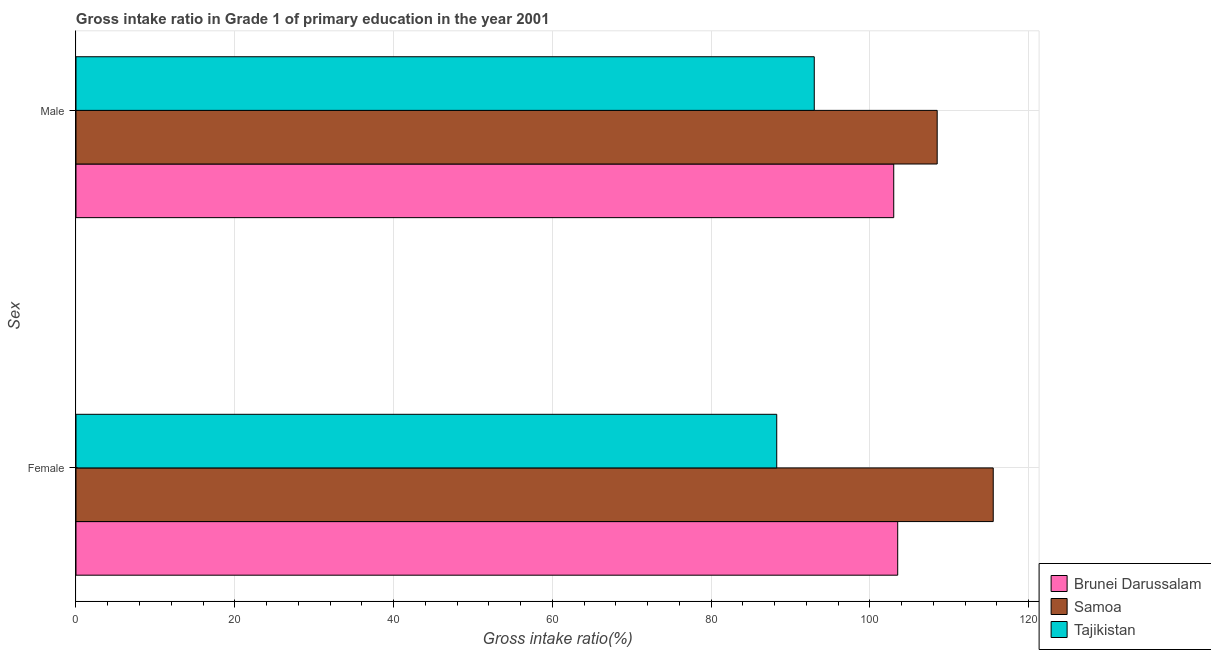How many different coloured bars are there?
Provide a succinct answer. 3. How many bars are there on the 1st tick from the bottom?
Your answer should be compact. 3. What is the label of the 2nd group of bars from the top?
Your response must be concise. Female. What is the gross intake ratio(female) in Tajikistan?
Keep it short and to the point. 88.27. Across all countries, what is the maximum gross intake ratio(female)?
Your response must be concise. 115.54. Across all countries, what is the minimum gross intake ratio(female)?
Ensure brevity in your answer.  88.27. In which country was the gross intake ratio(male) maximum?
Ensure brevity in your answer.  Samoa. In which country was the gross intake ratio(male) minimum?
Give a very brief answer. Tajikistan. What is the total gross intake ratio(male) in the graph?
Keep it short and to the point. 304.48. What is the difference between the gross intake ratio(female) in Samoa and that in Brunei Darussalam?
Give a very brief answer. 12.03. What is the difference between the gross intake ratio(female) in Samoa and the gross intake ratio(male) in Brunei Darussalam?
Your response must be concise. 12.53. What is the average gross intake ratio(male) per country?
Your answer should be very brief. 101.49. What is the difference between the gross intake ratio(male) and gross intake ratio(female) in Brunei Darussalam?
Keep it short and to the point. -0.5. What is the ratio of the gross intake ratio(female) in Tajikistan to that in Samoa?
Provide a short and direct response. 0.76. In how many countries, is the gross intake ratio(male) greater than the average gross intake ratio(male) taken over all countries?
Provide a short and direct response. 2. What does the 2nd bar from the top in Male represents?
Make the answer very short. Samoa. What does the 1st bar from the bottom in Male represents?
Give a very brief answer. Brunei Darussalam. How many countries are there in the graph?
Make the answer very short. 3. Are the values on the major ticks of X-axis written in scientific E-notation?
Make the answer very short. No. Does the graph contain any zero values?
Offer a terse response. No. Does the graph contain grids?
Give a very brief answer. Yes. How many legend labels are there?
Offer a terse response. 3. How are the legend labels stacked?
Give a very brief answer. Vertical. What is the title of the graph?
Offer a very short reply. Gross intake ratio in Grade 1 of primary education in the year 2001. What is the label or title of the X-axis?
Make the answer very short. Gross intake ratio(%). What is the label or title of the Y-axis?
Give a very brief answer. Sex. What is the Gross intake ratio(%) of Brunei Darussalam in Female?
Make the answer very short. 103.5. What is the Gross intake ratio(%) in Samoa in Female?
Ensure brevity in your answer.  115.54. What is the Gross intake ratio(%) in Tajikistan in Female?
Provide a short and direct response. 88.27. What is the Gross intake ratio(%) in Brunei Darussalam in Male?
Your answer should be compact. 103. What is the Gross intake ratio(%) in Samoa in Male?
Provide a succinct answer. 108.48. What is the Gross intake ratio(%) of Tajikistan in Male?
Offer a very short reply. 92.99. Across all Sex, what is the maximum Gross intake ratio(%) of Brunei Darussalam?
Make the answer very short. 103.5. Across all Sex, what is the maximum Gross intake ratio(%) of Samoa?
Provide a short and direct response. 115.54. Across all Sex, what is the maximum Gross intake ratio(%) in Tajikistan?
Make the answer very short. 92.99. Across all Sex, what is the minimum Gross intake ratio(%) of Brunei Darussalam?
Offer a terse response. 103. Across all Sex, what is the minimum Gross intake ratio(%) in Samoa?
Offer a terse response. 108.48. Across all Sex, what is the minimum Gross intake ratio(%) in Tajikistan?
Offer a terse response. 88.27. What is the total Gross intake ratio(%) of Brunei Darussalam in the graph?
Your response must be concise. 206.51. What is the total Gross intake ratio(%) of Samoa in the graph?
Keep it short and to the point. 224.02. What is the total Gross intake ratio(%) in Tajikistan in the graph?
Give a very brief answer. 181.26. What is the difference between the Gross intake ratio(%) in Brunei Darussalam in Female and that in Male?
Keep it short and to the point. 0.5. What is the difference between the Gross intake ratio(%) in Samoa in Female and that in Male?
Your response must be concise. 7.06. What is the difference between the Gross intake ratio(%) of Tajikistan in Female and that in Male?
Offer a very short reply. -4.73. What is the difference between the Gross intake ratio(%) of Brunei Darussalam in Female and the Gross intake ratio(%) of Samoa in Male?
Keep it short and to the point. -4.97. What is the difference between the Gross intake ratio(%) in Brunei Darussalam in Female and the Gross intake ratio(%) in Tajikistan in Male?
Provide a short and direct response. 10.51. What is the difference between the Gross intake ratio(%) of Samoa in Female and the Gross intake ratio(%) of Tajikistan in Male?
Provide a short and direct response. 22.54. What is the average Gross intake ratio(%) in Brunei Darussalam per Sex?
Ensure brevity in your answer.  103.25. What is the average Gross intake ratio(%) of Samoa per Sex?
Offer a very short reply. 112.01. What is the average Gross intake ratio(%) of Tajikistan per Sex?
Your answer should be compact. 90.63. What is the difference between the Gross intake ratio(%) of Brunei Darussalam and Gross intake ratio(%) of Samoa in Female?
Your answer should be very brief. -12.03. What is the difference between the Gross intake ratio(%) of Brunei Darussalam and Gross intake ratio(%) of Tajikistan in Female?
Make the answer very short. 15.24. What is the difference between the Gross intake ratio(%) in Samoa and Gross intake ratio(%) in Tajikistan in Female?
Provide a short and direct response. 27.27. What is the difference between the Gross intake ratio(%) of Brunei Darussalam and Gross intake ratio(%) of Samoa in Male?
Ensure brevity in your answer.  -5.47. What is the difference between the Gross intake ratio(%) in Brunei Darussalam and Gross intake ratio(%) in Tajikistan in Male?
Make the answer very short. 10.01. What is the difference between the Gross intake ratio(%) of Samoa and Gross intake ratio(%) of Tajikistan in Male?
Provide a short and direct response. 15.48. What is the ratio of the Gross intake ratio(%) of Brunei Darussalam in Female to that in Male?
Your answer should be very brief. 1. What is the ratio of the Gross intake ratio(%) in Samoa in Female to that in Male?
Keep it short and to the point. 1.07. What is the ratio of the Gross intake ratio(%) of Tajikistan in Female to that in Male?
Ensure brevity in your answer.  0.95. What is the difference between the highest and the second highest Gross intake ratio(%) of Brunei Darussalam?
Provide a short and direct response. 0.5. What is the difference between the highest and the second highest Gross intake ratio(%) of Samoa?
Your answer should be compact. 7.06. What is the difference between the highest and the second highest Gross intake ratio(%) of Tajikistan?
Make the answer very short. 4.73. What is the difference between the highest and the lowest Gross intake ratio(%) of Brunei Darussalam?
Provide a short and direct response. 0.5. What is the difference between the highest and the lowest Gross intake ratio(%) of Samoa?
Provide a short and direct response. 7.06. What is the difference between the highest and the lowest Gross intake ratio(%) of Tajikistan?
Provide a short and direct response. 4.73. 